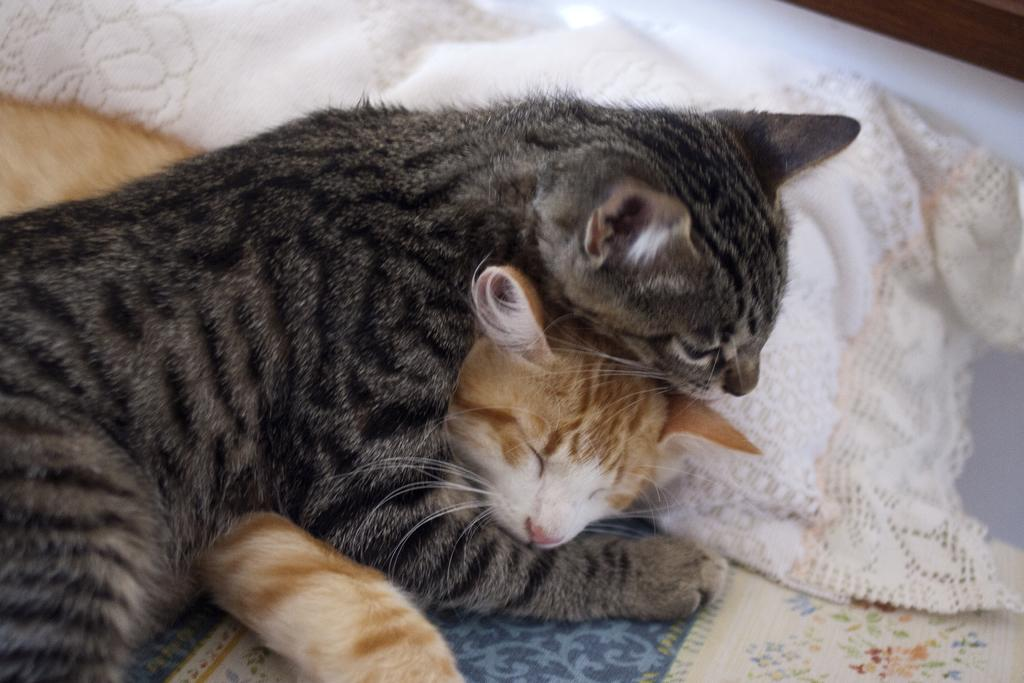How many cats are present in the image? There are two cats in the image. Can you describe the position or state of the cats in the image? The cats are on a surface in the image. What type of glove is the cat wearing in the image? There is no glove present on the cats in the image. What kind of pest can be seen being controlled by the cats in the image? There is no pest present in the image; the cats are simply on a surface. 